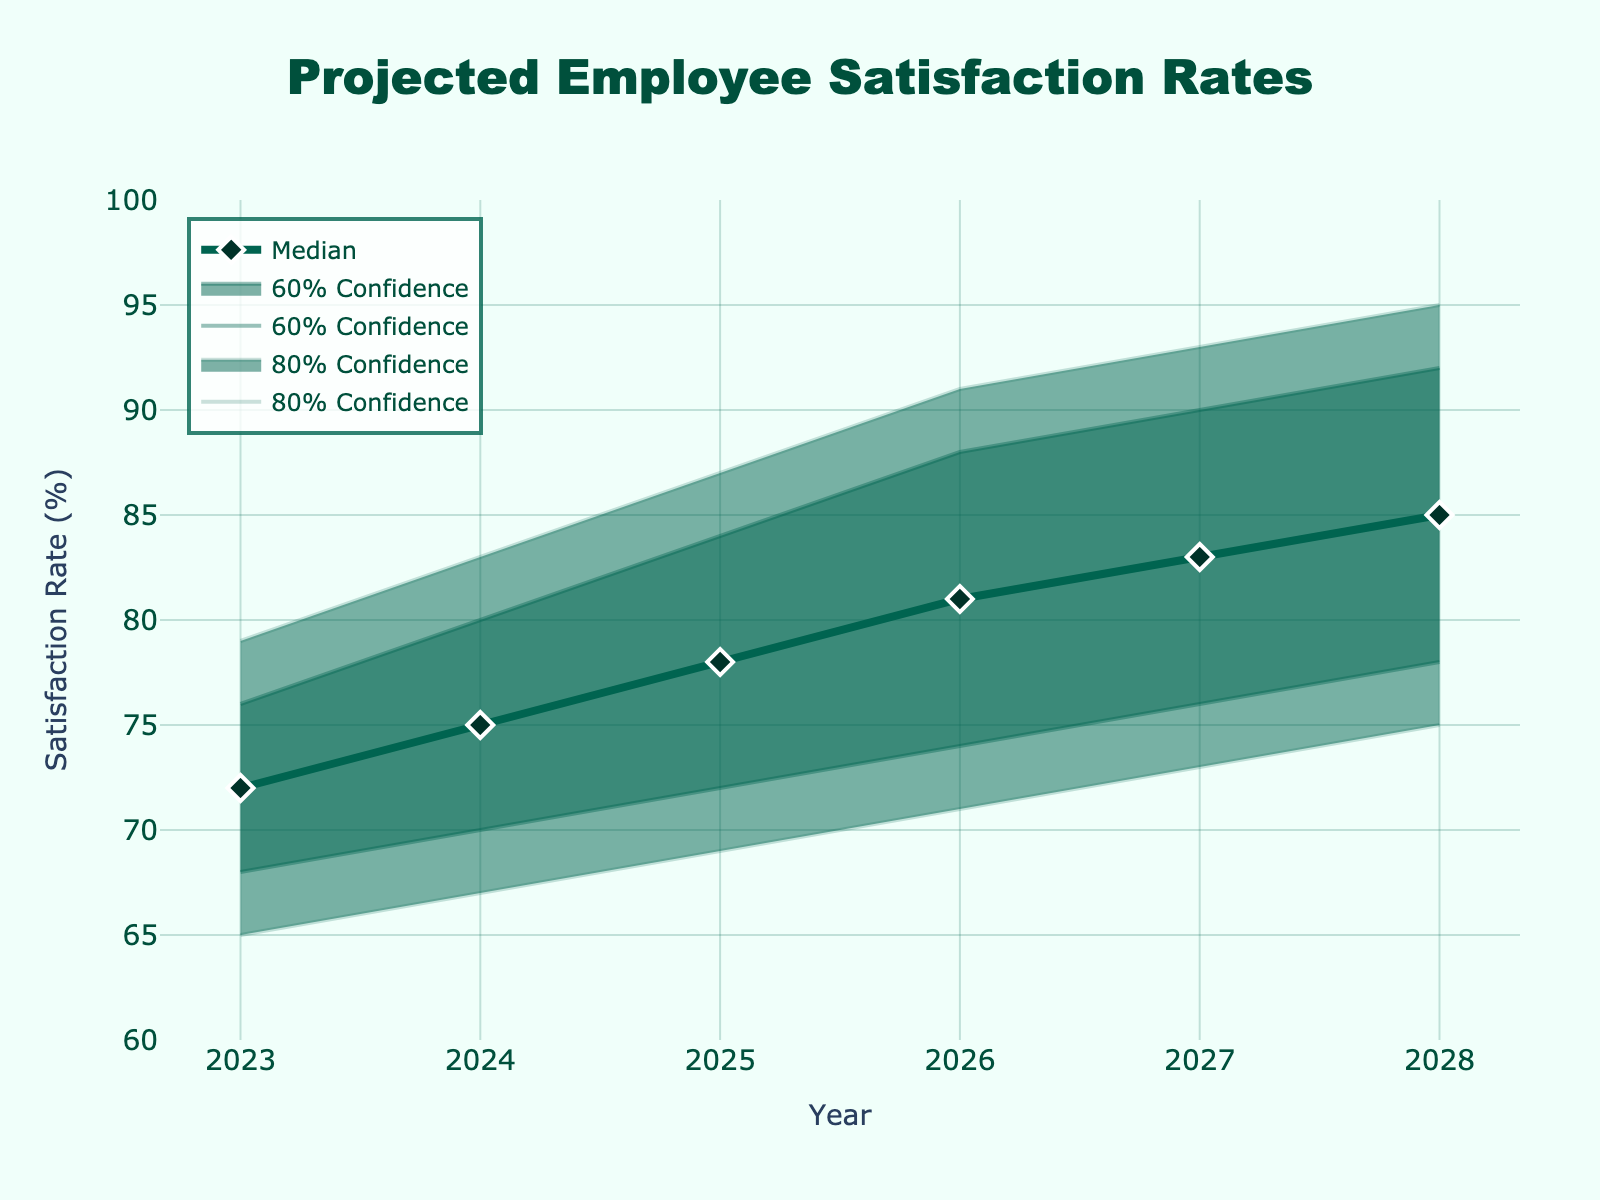What's the title of the figure? The title is typically located at the top of the figure. In this case, the title reads "Projected Employee Satisfaction Rates".
Answer: Projected Employee Satisfaction Rates What is the median projected employee satisfaction rate in 2026? Look at the year 2026 on the x-axis and find the corresponding median satisfaction rate on the y-axis, which is indicated by the prominent line with markers.
Answer: 81% How many years are projected in the fan chart? Count the number of data points along the x-axis, which represent years from the start to the end of the projection. The years given are 2023, 2024, 2025, 2026, 2027, and 2028.
Answer: 6 years What's the range of the 80% confidence interval for 2025? The 80% confidence interval is represented by the outermost shaded area. For 2025, look at 'Low20' and 'High20' at that year. The interval ranges from 69% to 87%.
Answer: 69% to 87% How does the median satisfaction rate change from 2024 to 2025? Find the median satisfaction rates for both years and calculate the difference. For 2024 it is 75%, and for 2025 it is 78%. Subtracting these gives a difference of 3%.
Answer: 3% Which year shows the highest projected median satisfaction rate and what is the value? Identify the highest median value on the main line with markers. The year is 2028 and the median satisfaction rate for that year is 85%.
Answer: 2028, 85% Is the range of the 60% confidence interval increasing or decreasing over time? Observe the upper and lower bounds of the 60% confidence interval (High10 and Low10 lines) and note their spread each year. The interval appears to increase, signifying growing uncertainty.
Answer: Increasing What is the 60% confidence interval for 2027? Look at the year 2027 on the x-axis and identify the values for 'Low10' and 'High10'—those indicate the range for the 60% confidence interval.
Answer: 76% to 90% Does the plot background and the legend background color blend? Compare the plot background color and the legend background color. Neither blend entirely because the legend has a white background for better readability.
Answer: No Which color is used to represent the median line and markers? Identify the color used for the median line and markers, which is in a darker shade to stand out. The color is dark green.
Answer: Dark green 